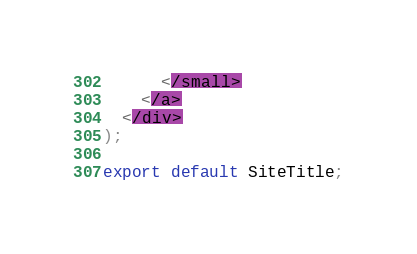<code> <loc_0><loc_0><loc_500><loc_500><_JavaScript_>      </small>
    </a>
  </div>
);

export default SiteTitle;
</code> 